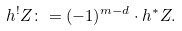Convert formula to latex. <formula><loc_0><loc_0><loc_500><loc_500>h ^ { ! } Z \colon = ( - 1 ) ^ { m - d } \cdot h ^ { \ast } Z .</formula> 